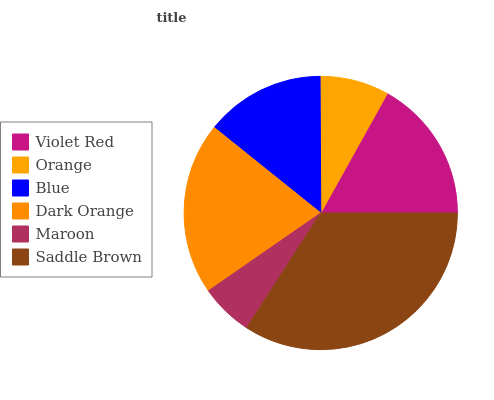Is Maroon the minimum?
Answer yes or no. Yes. Is Saddle Brown the maximum?
Answer yes or no. Yes. Is Orange the minimum?
Answer yes or no. No. Is Orange the maximum?
Answer yes or no. No. Is Violet Red greater than Orange?
Answer yes or no. Yes. Is Orange less than Violet Red?
Answer yes or no. Yes. Is Orange greater than Violet Red?
Answer yes or no. No. Is Violet Red less than Orange?
Answer yes or no. No. Is Violet Red the high median?
Answer yes or no. Yes. Is Blue the low median?
Answer yes or no. Yes. Is Dark Orange the high median?
Answer yes or no. No. Is Orange the low median?
Answer yes or no. No. 